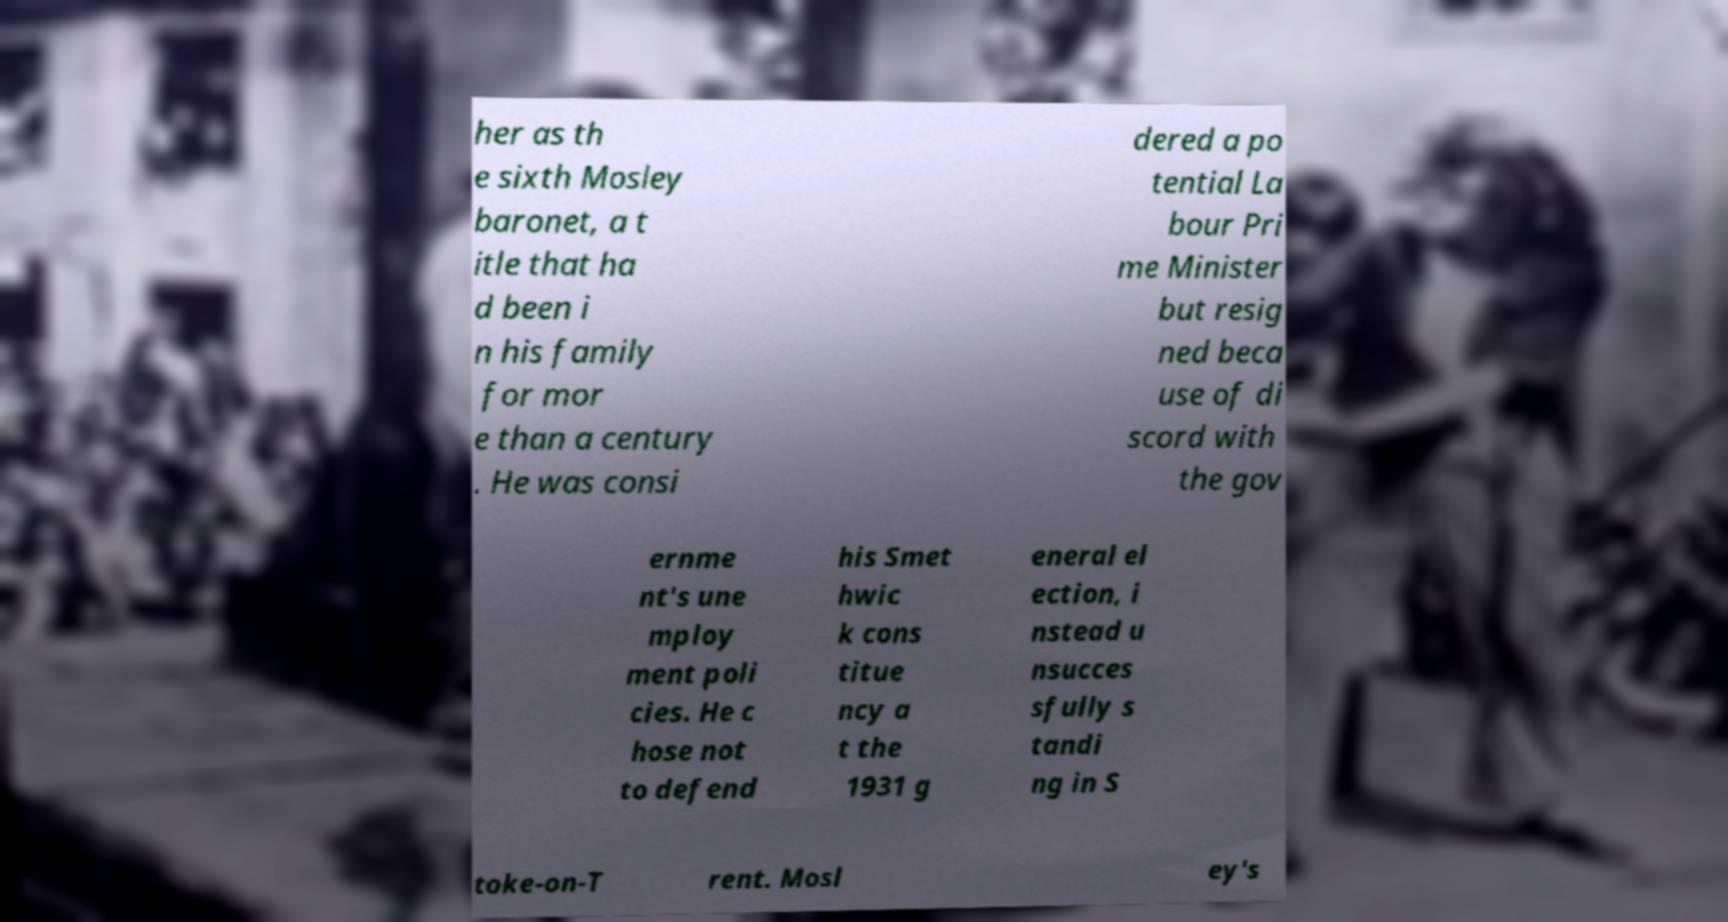Please read and relay the text visible in this image. What does it say? her as th e sixth Mosley baronet, a t itle that ha d been i n his family for mor e than a century . He was consi dered a po tential La bour Pri me Minister but resig ned beca use of di scord with the gov ernme nt's une mploy ment poli cies. He c hose not to defend his Smet hwic k cons titue ncy a t the 1931 g eneral el ection, i nstead u nsucces sfully s tandi ng in S toke-on-T rent. Mosl ey's 